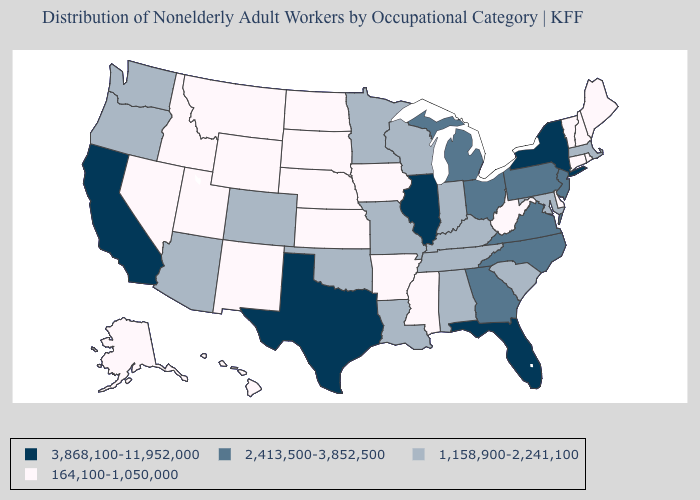What is the lowest value in the West?
Write a very short answer. 164,100-1,050,000. What is the lowest value in states that border Arizona?
Answer briefly. 164,100-1,050,000. Name the states that have a value in the range 1,158,900-2,241,100?
Give a very brief answer. Alabama, Arizona, Colorado, Indiana, Kentucky, Louisiana, Maryland, Massachusetts, Minnesota, Missouri, Oklahoma, Oregon, South Carolina, Tennessee, Washington, Wisconsin. Is the legend a continuous bar?
Write a very short answer. No. Does New York have the highest value in the Northeast?
Quick response, please. Yes. Which states have the highest value in the USA?
Short answer required. California, Florida, Illinois, New York, Texas. What is the value of Hawaii?
Answer briefly. 164,100-1,050,000. Name the states that have a value in the range 164,100-1,050,000?
Quick response, please. Alaska, Arkansas, Connecticut, Delaware, Hawaii, Idaho, Iowa, Kansas, Maine, Mississippi, Montana, Nebraska, Nevada, New Hampshire, New Mexico, North Dakota, Rhode Island, South Dakota, Utah, Vermont, West Virginia, Wyoming. Does Colorado have the lowest value in the West?
Concise answer only. No. Name the states that have a value in the range 164,100-1,050,000?
Quick response, please. Alaska, Arkansas, Connecticut, Delaware, Hawaii, Idaho, Iowa, Kansas, Maine, Mississippi, Montana, Nebraska, Nevada, New Hampshire, New Mexico, North Dakota, Rhode Island, South Dakota, Utah, Vermont, West Virginia, Wyoming. Name the states that have a value in the range 2,413,500-3,852,500?
Short answer required. Georgia, Michigan, New Jersey, North Carolina, Ohio, Pennsylvania, Virginia. Name the states that have a value in the range 164,100-1,050,000?
Short answer required. Alaska, Arkansas, Connecticut, Delaware, Hawaii, Idaho, Iowa, Kansas, Maine, Mississippi, Montana, Nebraska, Nevada, New Hampshire, New Mexico, North Dakota, Rhode Island, South Dakota, Utah, Vermont, West Virginia, Wyoming. Does Rhode Island have the same value as Maryland?
Quick response, please. No. Name the states that have a value in the range 2,413,500-3,852,500?
Answer briefly. Georgia, Michigan, New Jersey, North Carolina, Ohio, Pennsylvania, Virginia. Name the states that have a value in the range 3,868,100-11,952,000?
Be succinct. California, Florida, Illinois, New York, Texas. 